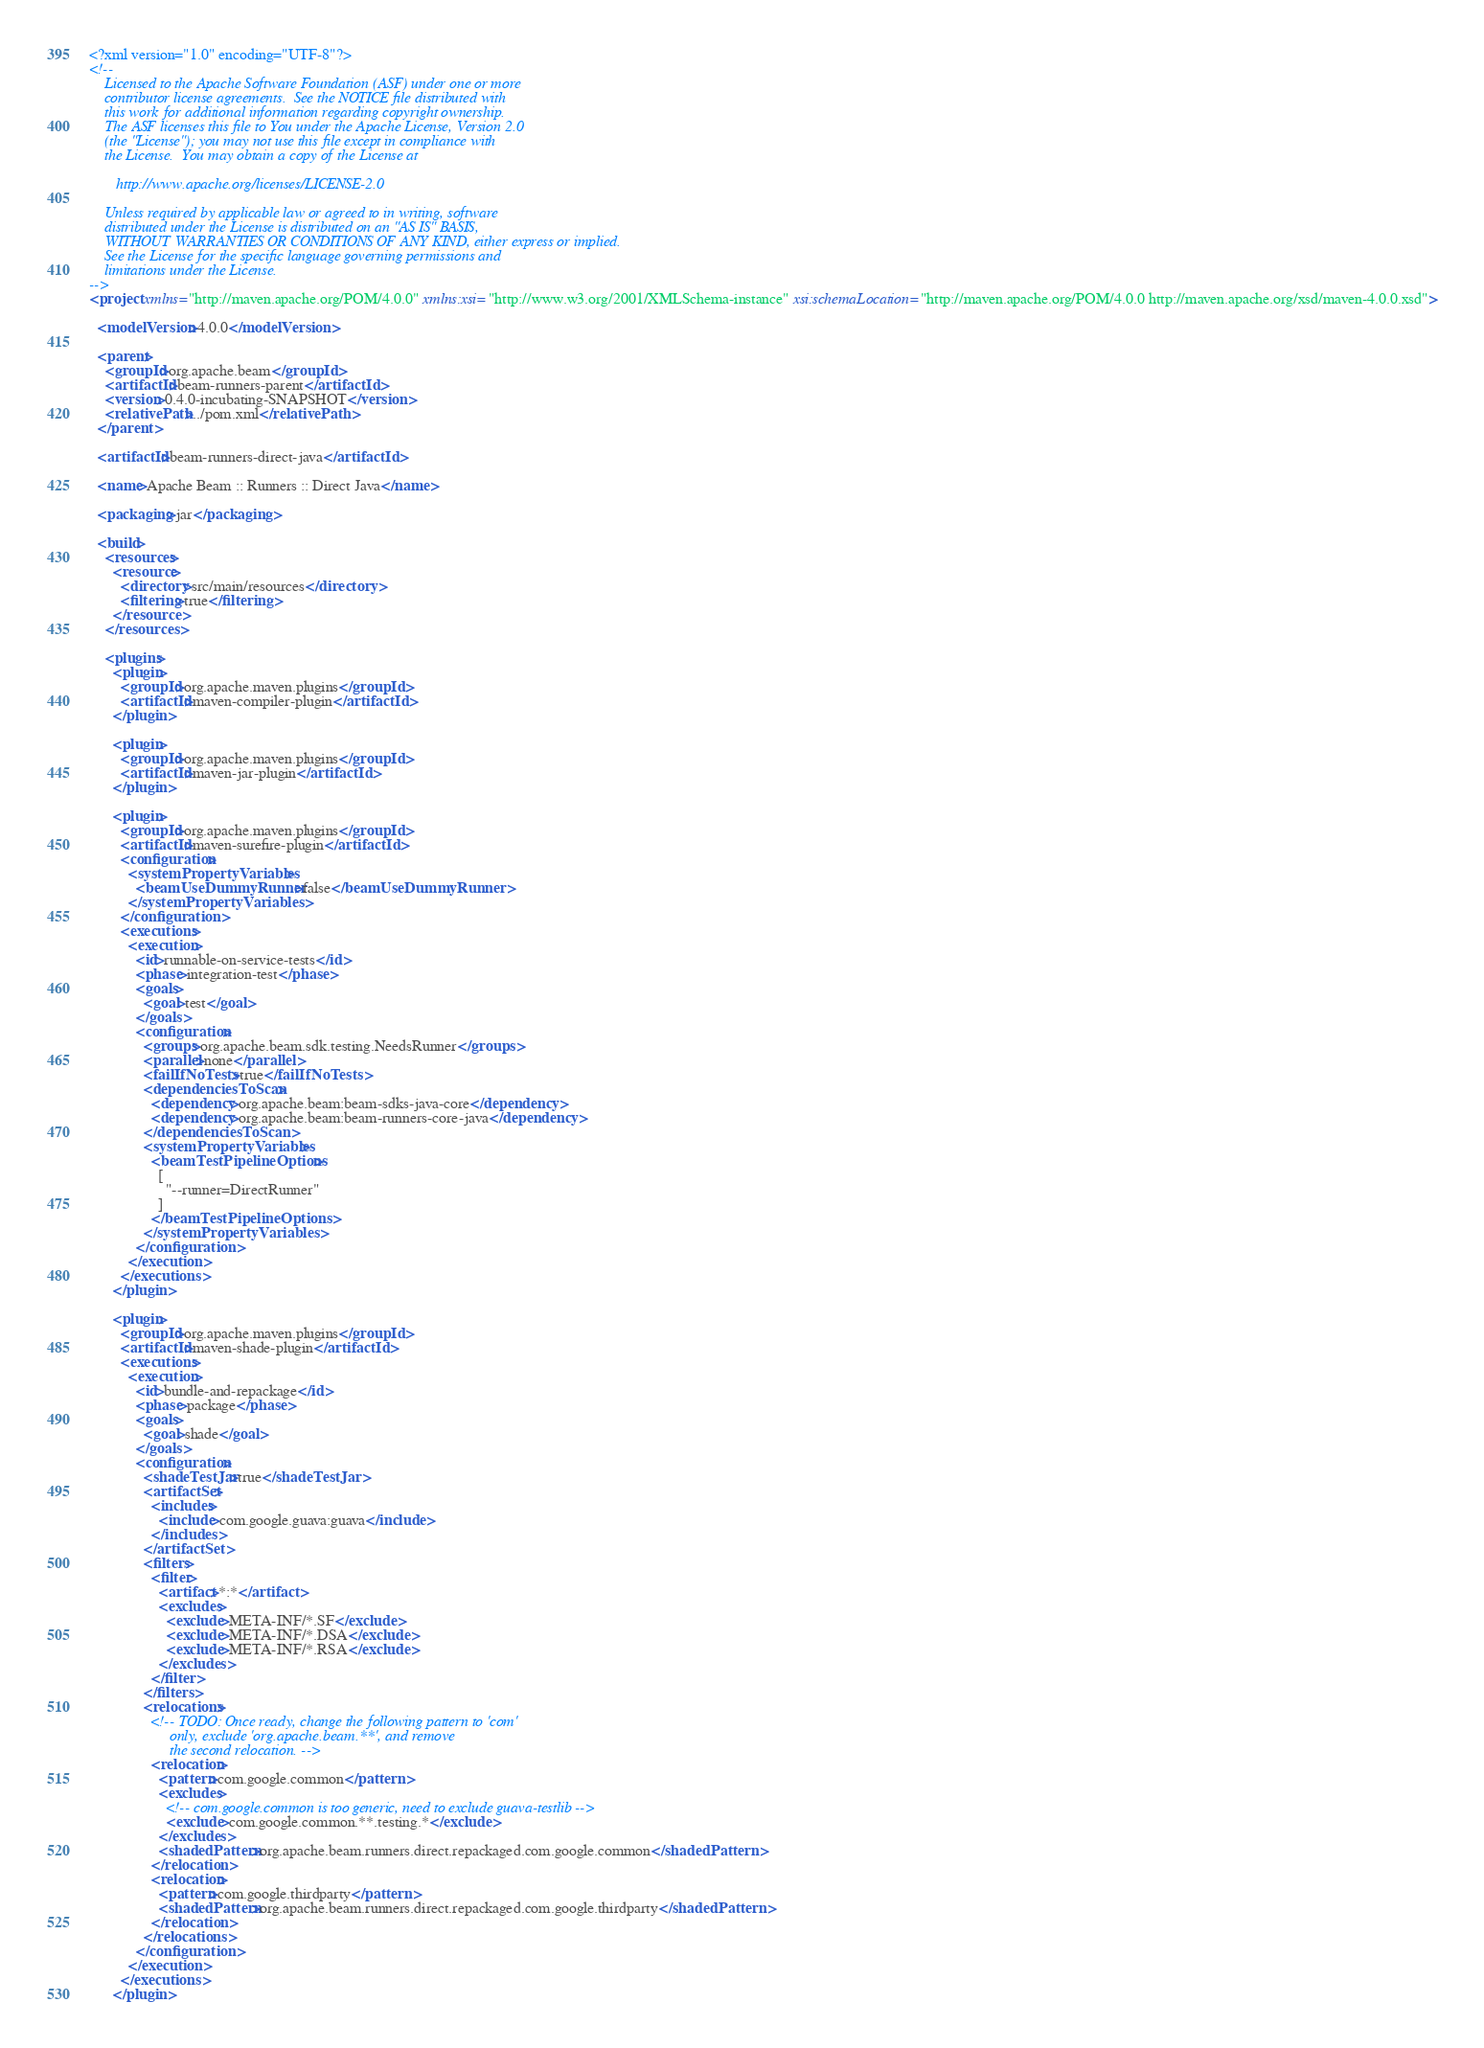<code> <loc_0><loc_0><loc_500><loc_500><_XML_><?xml version="1.0" encoding="UTF-8"?>
<!--
    Licensed to the Apache Software Foundation (ASF) under one or more
    contributor license agreements.  See the NOTICE file distributed with
    this work for additional information regarding copyright ownership.
    The ASF licenses this file to You under the Apache License, Version 2.0
    (the "License"); you may not use this file except in compliance with
    the License.  You may obtain a copy of the License at

       http://www.apache.org/licenses/LICENSE-2.0

    Unless required by applicable law or agreed to in writing, software
    distributed under the License is distributed on an "AS IS" BASIS,
    WITHOUT WARRANTIES OR CONDITIONS OF ANY KIND, either express or implied.
    See the License for the specific language governing permissions and
    limitations under the License.
-->
<project xmlns="http://maven.apache.org/POM/4.0.0" xmlns:xsi="http://www.w3.org/2001/XMLSchema-instance" xsi:schemaLocation="http://maven.apache.org/POM/4.0.0 http://maven.apache.org/xsd/maven-4.0.0.xsd">

  <modelVersion>4.0.0</modelVersion>

  <parent>
    <groupId>org.apache.beam</groupId>
    <artifactId>beam-runners-parent</artifactId>
    <version>0.4.0-incubating-SNAPSHOT</version>
    <relativePath>../pom.xml</relativePath>
  </parent>

  <artifactId>beam-runners-direct-java</artifactId>

  <name>Apache Beam :: Runners :: Direct Java</name>

  <packaging>jar</packaging>

  <build>
    <resources>
      <resource>
        <directory>src/main/resources</directory>
        <filtering>true</filtering>
      </resource>
    </resources>

    <plugins>
      <plugin>
        <groupId>org.apache.maven.plugins</groupId>
        <artifactId>maven-compiler-plugin</artifactId>
      </plugin>

      <plugin>
        <groupId>org.apache.maven.plugins</groupId>
        <artifactId>maven-jar-plugin</artifactId>
      </plugin>

      <plugin>
        <groupId>org.apache.maven.plugins</groupId>
        <artifactId>maven-surefire-plugin</artifactId>
        <configuration>
          <systemPropertyVariables>
            <beamUseDummyRunner>false</beamUseDummyRunner>
          </systemPropertyVariables>
        </configuration>
        <executions>
          <execution>
            <id>runnable-on-service-tests</id>
            <phase>integration-test</phase>
            <goals>
              <goal>test</goal>
            </goals>
            <configuration>
              <groups>org.apache.beam.sdk.testing.NeedsRunner</groups>
              <parallel>none</parallel>
              <failIfNoTests>true</failIfNoTests>
              <dependenciesToScan>
                <dependency>org.apache.beam:beam-sdks-java-core</dependency>
                <dependency>org.apache.beam:beam-runners-core-java</dependency>
              </dependenciesToScan>
              <systemPropertyVariables>
                <beamTestPipelineOptions>
                  [
                    "--runner=DirectRunner"
                  ]
                </beamTestPipelineOptions>
              </systemPropertyVariables>
            </configuration>
          </execution>
        </executions>
      </plugin>

      <plugin>
        <groupId>org.apache.maven.plugins</groupId>
        <artifactId>maven-shade-plugin</artifactId>
        <executions>
          <execution>
            <id>bundle-and-repackage</id>
            <phase>package</phase>
            <goals>
              <goal>shade</goal>
            </goals>
            <configuration>
              <shadeTestJar>true</shadeTestJar>
              <artifactSet>
                <includes>
                  <include>com.google.guava:guava</include>
                </includes>
              </artifactSet>
              <filters>
                <filter>
                  <artifact>*:*</artifact>
                  <excludes>
                    <exclude>META-INF/*.SF</exclude>
                    <exclude>META-INF/*.DSA</exclude>
                    <exclude>META-INF/*.RSA</exclude>
                  </excludes>
                </filter>
              </filters>
              <relocations>
                <!-- TODO: Once ready, change the following pattern to 'com'
                     only, exclude 'org.apache.beam.**', and remove
                     the second relocation. -->
                <relocation>
                  <pattern>com.google.common</pattern>
                  <excludes>
                    <!-- com.google.common is too generic, need to exclude guava-testlib -->
                    <exclude>com.google.common.**.testing.*</exclude>
                  </excludes>
                  <shadedPattern>org.apache.beam.runners.direct.repackaged.com.google.common</shadedPattern>
                </relocation>
                <relocation>
                  <pattern>com.google.thirdparty</pattern>
                  <shadedPattern>org.apache.beam.runners.direct.repackaged.com.google.thirdparty</shadedPattern>
                </relocation>
              </relocations>
            </configuration>
          </execution>
        </executions>
      </plugin>
</code> 